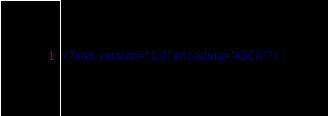Convert code to text. <code><loc_0><loc_0><loc_500><loc_500><_XML_><?xml version="1.0" encoding="ASCII"?></code> 